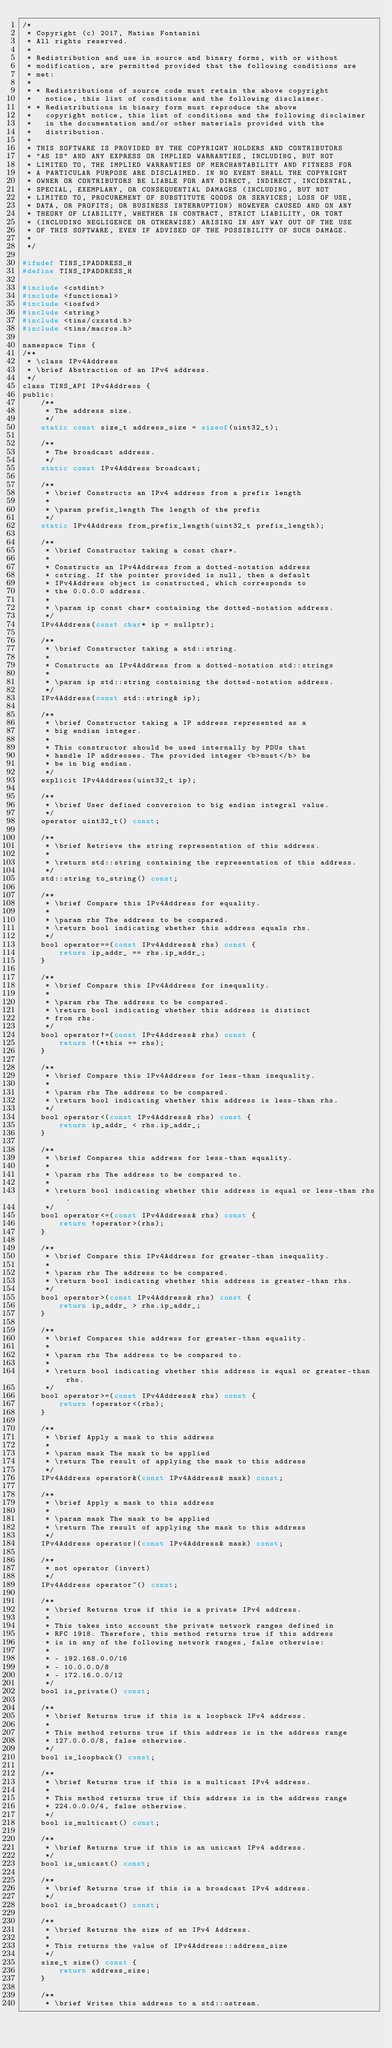Convert code to text. <code><loc_0><loc_0><loc_500><loc_500><_C_>/*
 * Copyright (c) 2017, Matias Fontanini
 * All rights reserved.
 *
 * Redistribution and use in source and binary forms, with or without
 * modification, are permitted provided that the following conditions are
 * met:
 * 
 * * Redistributions of source code must retain the above copyright
 *   notice, this list of conditions and the following disclaimer.
 * * Redistributions in binary form must reproduce the above
 *   copyright notice, this list of conditions and the following disclaimer
 *   in the documentation and/or other materials provided with the
 *   distribution.
 * 
 * THIS SOFTWARE IS PROVIDED BY THE COPYRIGHT HOLDERS AND CONTRIBUTORS
 * "AS IS" AND ANY EXPRESS OR IMPLIED WARRANTIES, INCLUDING, BUT NOT
 * LIMITED TO, THE IMPLIED WARRANTIES OF MERCHANTABILITY AND FITNESS FOR
 * A PARTICULAR PURPOSE ARE DISCLAIMED. IN NO EVENT SHALL THE COPYRIGHT
 * OWNER OR CONTRIBUTORS BE LIABLE FOR ANY DIRECT, INDIRECT, INCIDENTAL,
 * SPECIAL, EXEMPLARY, OR CONSEQUENTIAL DAMAGES (INCLUDING, BUT NOT
 * LIMITED TO, PROCUREMENT OF SUBSTITUTE GOODS OR SERVICES; LOSS OF USE,
 * DATA, OR PROFITS; OR BUSINESS INTERRUPTION) HOWEVER CAUSED AND ON ANY
 * THEORY OF LIABILITY, WHETHER IN CONTRACT, STRICT LIABILITY, OR TORT
 * (INCLUDING NEGLIGENCE OR OTHERWISE) ARISING IN ANY WAY OUT OF THE USE
 * OF THIS SOFTWARE, EVEN IF ADVISED OF THE POSSIBILITY OF SUCH DAMAGE.
 *
 */

#ifndef TINS_IPADDRESS_H
#define TINS_IPADDRESS_H

#include <cstdint>
#include <functional>
#include <iosfwd>
#include <string>
#include <tins/cxxstd.h>
#include <tins/macros.h>

namespace Tins {
/**
 * \class IPv4Address
 * \brief Abstraction of an IPv4 address.
 */
class TINS_API IPv4Address {
public:
    /**
     * The address size.
     */
    static const size_t address_size = sizeof(uint32_t);

    /**
     * The broadcast address.
     */
    static const IPv4Address broadcast;

    /**
     * \brief Constructs an IPv4 address from a prefix length
     *
     * \param prefix_length The length of the prefix
     */
    static IPv4Address from_prefix_length(uint32_t prefix_length);

    /**
     * \brief Constructor taking a const char*.
     * 
     * Constructs an IPv4Address from a dotted-notation address 
     * cstring. If the pointer provided is null, then a default 
     * IPv4Address object is constructed, which corresponds to 
     * the 0.0.0.0 address.
     * 
     * \param ip const char* containing the dotted-notation address.
     */
    IPv4Address(const char* ip = nullptr);
    
    /**
     * \brief Constructor taking a std::string.
     * 
     * Constructs an IPv4Address from a dotted-notation std::strings
     * 
     * \param ip std::string containing the dotted-notation address.
     */
    IPv4Address(const std::string& ip);
    
    /**
     * \brief Constructor taking a IP address represented as a
     * big endian integer.
     * 
     * This constructor should be used internally by PDUs that
     * handle IP addresses. The provided integer <b>must</b> be
     * be in big endian.
     */
    explicit IPv4Address(uint32_t ip);
    
    /**
     * \brief User defined conversion to big endian integral value.
     */
    operator uint32_t() const;
    
    /**
     * \brief Retrieve the string representation of this address.
     * 
     * \return std::string containing the representation of this address.
     */
    std::string to_string() const;
    
    /**
     * \brief Compare this IPv4Address for equality.
     * 
     * \param rhs The address to be compared.
     * \return bool indicating whether this address equals rhs.
     */
    bool operator==(const IPv4Address& rhs) const {
        return ip_addr_ == rhs.ip_addr_;
    }
    
    /**
     * \brief Compare this IPv4Address for inequality.
     * 
     * \param rhs The address to be compared.
     * \return bool indicating whether this address is distinct 
     * from rhs.
     */
    bool operator!=(const IPv4Address& rhs) const {
        return !(*this == rhs);
    }
    
    /**
     * \brief Compare this IPv4Address for less-than inequality.
     * 
     * \param rhs The address to be compared.
     * \return bool indicating whether this address is less-than rhs.
     */
    bool operator<(const IPv4Address& rhs) const {
        return ip_addr_ < rhs.ip_addr_;
    }

    /**
     * \brief Compares this address for less-than equality.
     *
     * \param rhs The address to be compared to.
     *
     * \return bool indicating whether this address is equal or less-than rhs.
     */
    bool operator<=(const IPv4Address& rhs) const {
        return !operator>(rhs);
    }

    /**
     * \brief Compare this IPv4Address for greater-than inequality.
     *
     * \param rhs The address to be compared.
     * \return bool indicating whether this address is greater-than rhs.
     */
    bool operator>(const IPv4Address& rhs) const {
        return ip_addr_ > rhs.ip_addr_;
    }

    /**
     * \brief Compares this address for greater-than equality.
     *
     * \param rhs The address to be compared to.
     *
     * \return bool indicating whether this address is equal or greater-than rhs.
     */
    bool operator>=(const IPv4Address& rhs) const {
        return !operator<(rhs);
    }

    /**
     * \brief Apply a mask to this address
     * 
     * \param mask The mask to be applied
     * \return The result of applying the mask to this address
     */
    IPv4Address operator&(const IPv4Address& mask) const;

    /**
     * \brief Apply a mask to this address
     *
     * \param mask The mask to be applied
     * \return The result of applying the mask to this address
     */
    IPv4Address operator|(const IPv4Address& mask) const;

    /**
     * not operator (invert)
     */
    IPv4Address operator~() const;
    
    /**
     * \brief Returns true if this is a private IPv4 address.
     * 
     * This takes into account the private network ranges defined in
     * RFC 1918. Therefore, this method returns true if this address
     * is in any of the following network ranges, false otherwise:
     * 
     * - 192.168.0.0/16
     * - 10.0.0.0/8
     * - 172.16.0.0/12
     */
    bool is_private() const;
    
    /**
     * \brief Returns true if this is a loopback IPv4 address.
     * 
     * This method returns true if this address is in the address range
     * 127.0.0.0/8, false otherwise.
     */
    bool is_loopback() const;

    /**
     * \brief Returns true if this is a multicast IPv4 address.
     * 
     * This method returns true if this address is in the address range
     * 224.0.0.0/4, false otherwise.
     */
    bool is_multicast() const;

    /**
     * \brief Returns true if this is an unicast IPv4 address.
     */
    bool is_unicast() const;

    /**
     * \brief Returns true if this is a broadcast IPv4 address.
     */
    bool is_broadcast() const;

    /**
     * \brief Returns the size of an IPv4 Address.
     *
     * This returns the value of IPv4Address::address_size
     */
    size_t size() const {
        return address_size;
    }
    
    /**
     * \brief Writes this address to a std::ostream.</code> 